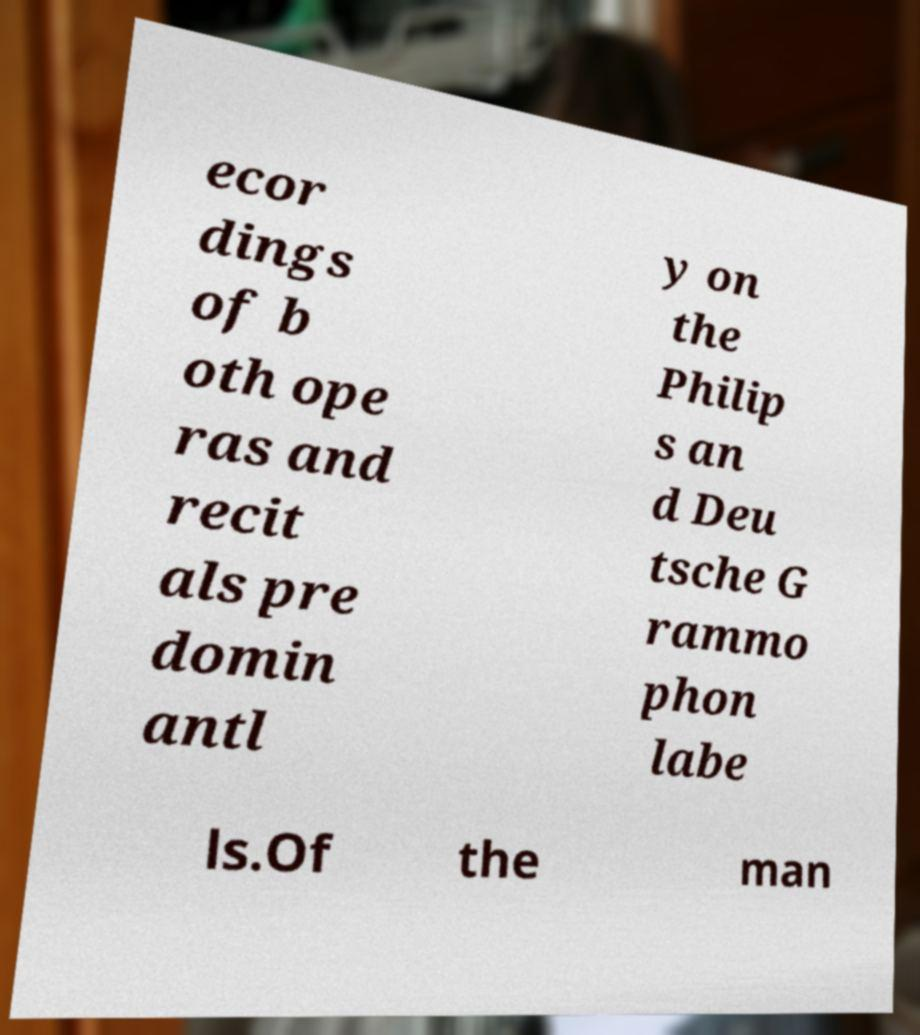For documentation purposes, I need the text within this image transcribed. Could you provide that? ecor dings of b oth ope ras and recit als pre domin antl y on the Philip s an d Deu tsche G rammo phon labe ls.Of the man 